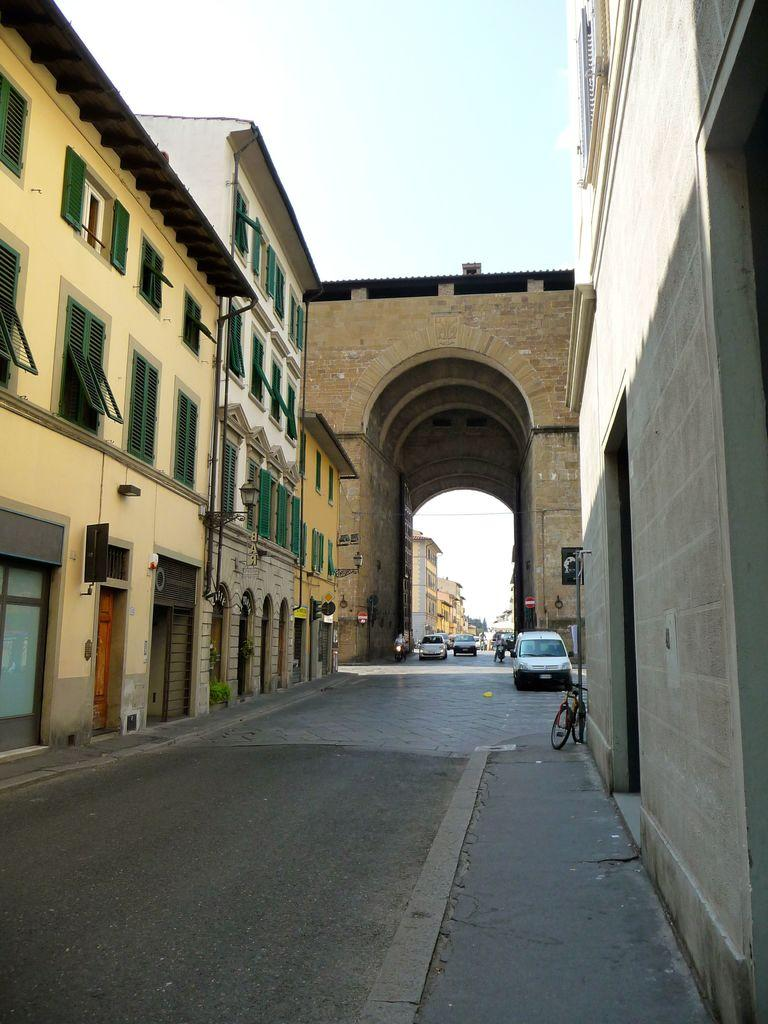What is the main feature of the image? The main feature of the image is a road. Where is the road located in relation to other structures? The road is between buildings. What architectural element can be seen in the middle of the image? There is an arch in the middle of the image. What is visible at the top of the image? The sky is visible at the top of the image. What type of hook can be seen hanging from the arch in the image? There is no hook present in the image; it features a road, buildings, and an arch. What is the chance of a battle occurring in the image? There is no indication of a battle or any conflict in the image. 